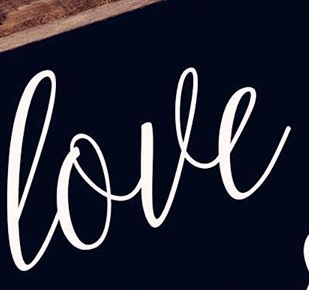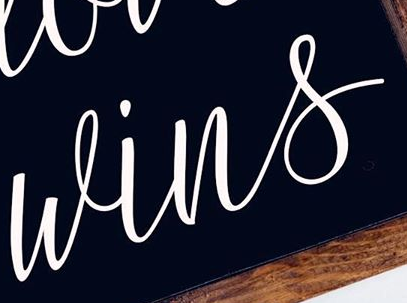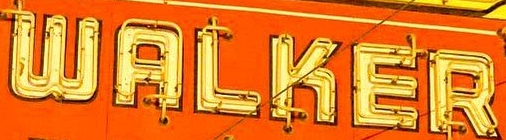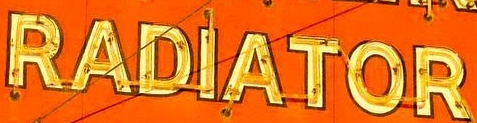Read the text content from these images in order, separated by a semicolon. love; wins; WALKER; RADIATOR 